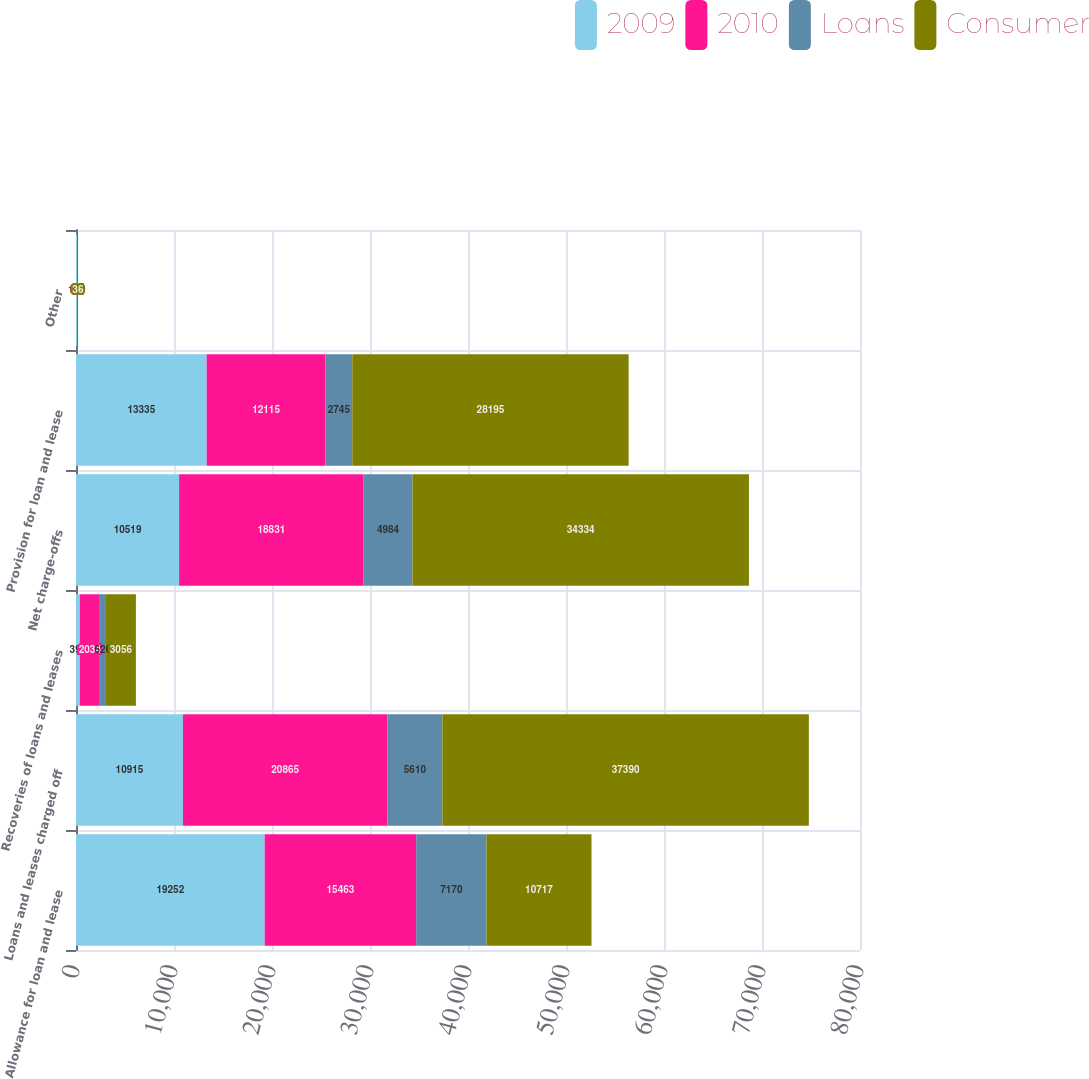<chart> <loc_0><loc_0><loc_500><loc_500><stacked_bar_chart><ecel><fcel>Allowance for loan and lease<fcel>Loans and leases charged off<fcel>Recoveries of loans and leases<fcel>Net charge-offs<fcel>Provision for loan and lease<fcel>Other<nl><fcel>2009<fcel>19252<fcel>10915<fcel>396<fcel>10519<fcel>13335<fcel>107<nl><fcel>2010<fcel>15463<fcel>20865<fcel>2034<fcel>18831<fcel>12115<fcel>64<nl><fcel>Loans<fcel>7170<fcel>5610<fcel>626<fcel>4984<fcel>2745<fcel>7<nl><fcel>Consumer<fcel>10717<fcel>37390<fcel>3056<fcel>34334<fcel>28195<fcel>36<nl></chart> 